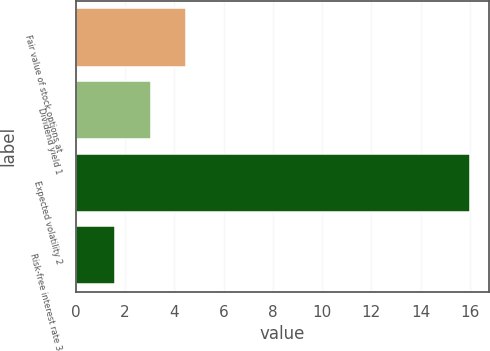<chart> <loc_0><loc_0><loc_500><loc_500><bar_chart><fcel>Fair value of stock options at<fcel>Dividend yield 1<fcel>Expected volatility 2<fcel>Risk-free interest rate 3<nl><fcel>4.48<fcel>3.04<fcel>16<fcel>1.6<nl></chart> 